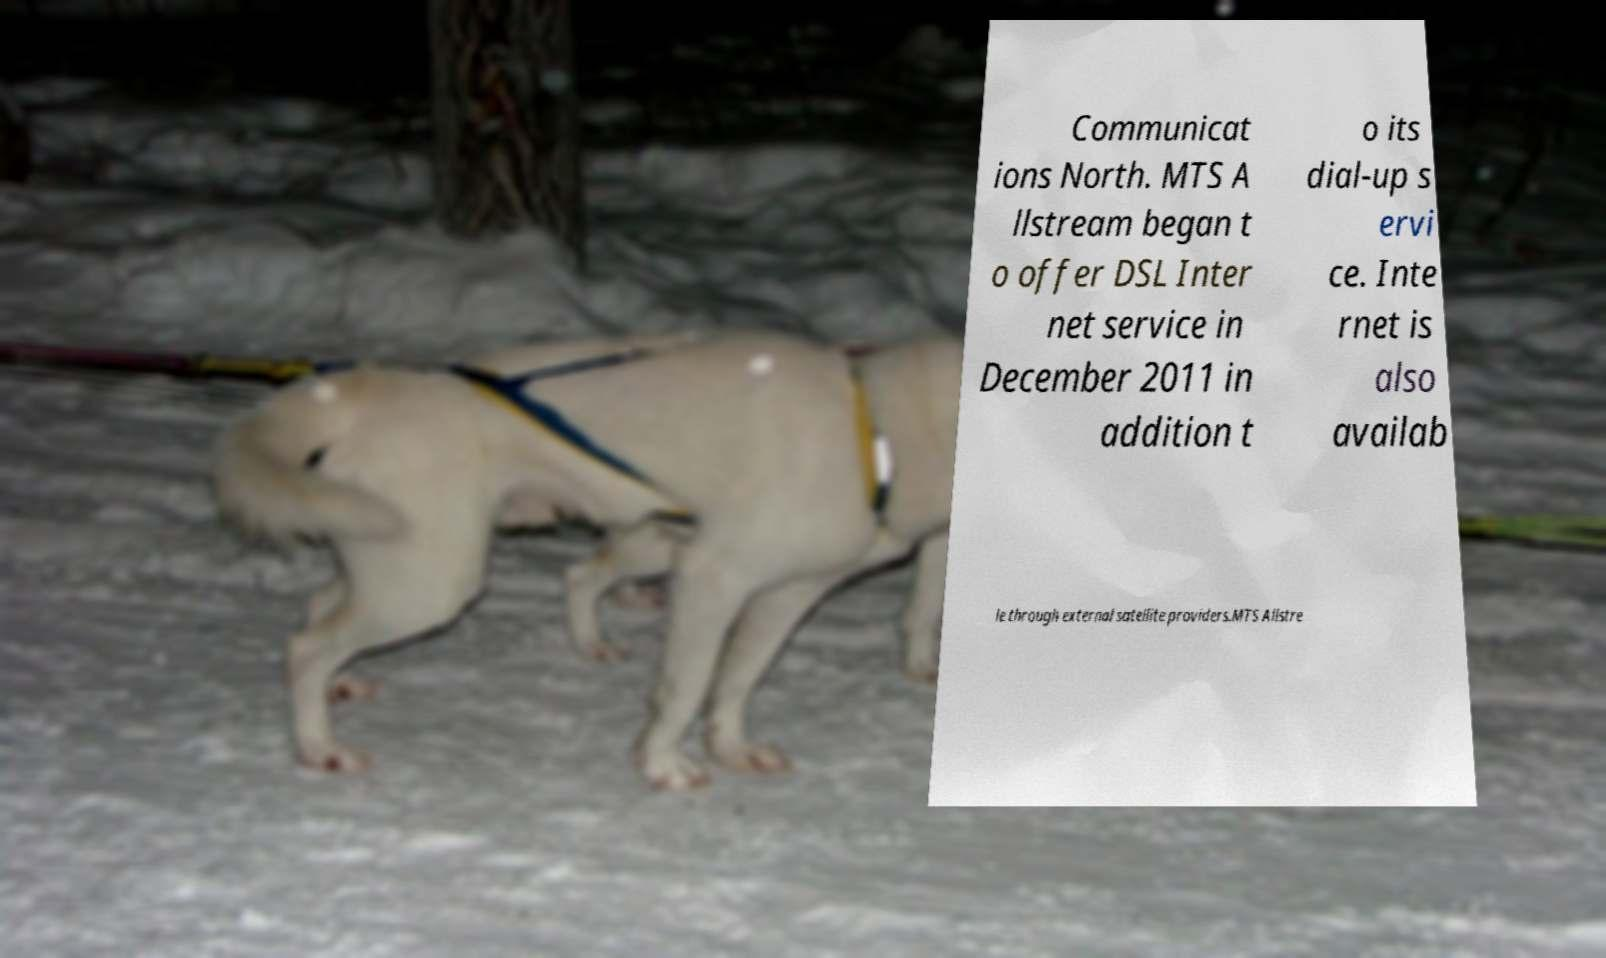Could you extract and type out the text from this image? Communicat ions North. MTS A llstream began t o offer DSL Inter net service in December 2011 in addition t o its dial-up s ervi ce. Inte rnet is also availab le through external satellite providers.MTS Allstre 